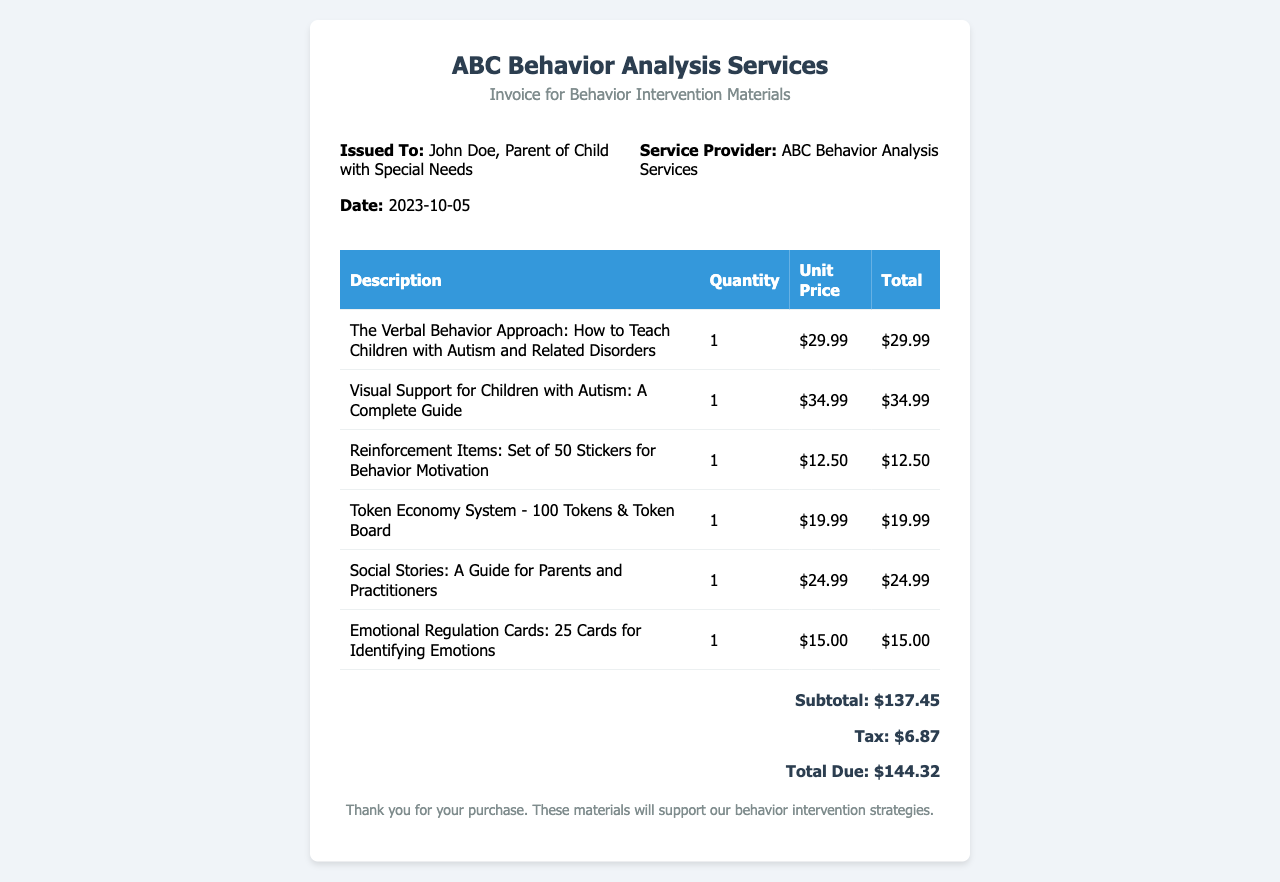What is the date of the invoice? The date of the invoice is listed in the document, which is October 5, 2023.
Answer: 2023-10-05 Who is the service provider? The service provider's name is identified in the document header.
Answer: ABC Behavior Analysis Services What is the total due amount? The total due amount is presented in the total section of the receipt.
Answer: $144.32 How many visual aids were purchased? The document lists one item specifically categorized as a visual aid.
Answer: 1 What is the price of the “Token Economy System”? The price of the "Token Economy System" is specified in the itemized pricing table.
Answer: $19.99 Which book has the highest price? The document contains multiple books with listed prices; the one with the highest price will be the answer.
Answer: Visual Support for Children with Autism: A Complete Guide What is the subtotal amount before tax? The subtotal amount is presented in the total section of the receipt, indicating the total before adding tax.
Answer: $137.45 How many reinforcement items were purchased? Reinforcement items are listed separately in the document, and there is one reinforcement item purchased.
Answer: 1 What type of cards are included in the emotional regulation items? The item description in the document specifies the type of cards included.
Answer: Emotional Regulation Cards 